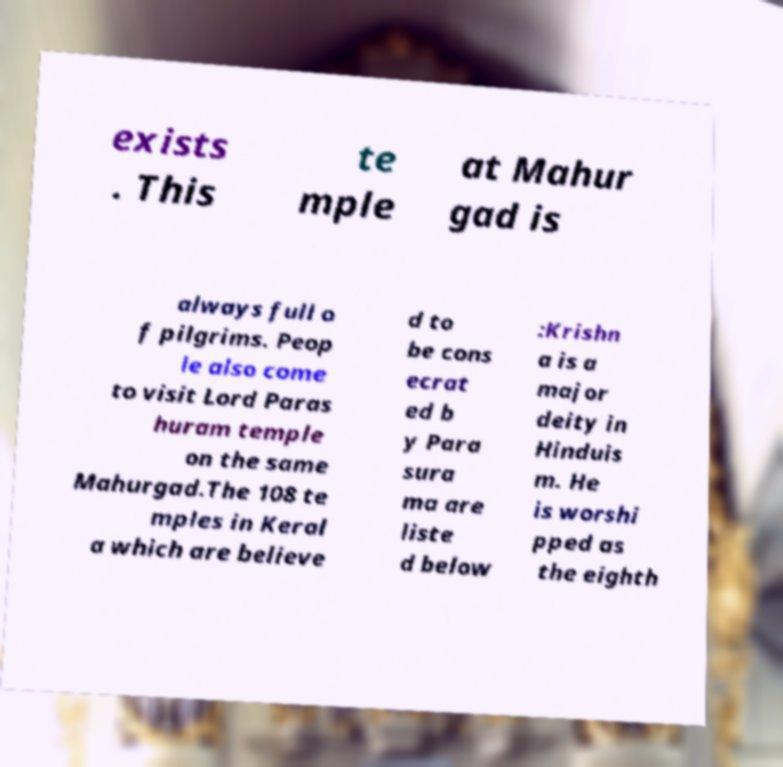Can you read and provide the text displayed in the image?This photo seems to have some interesting text. Can you extract and type it out for me? exists . This te mple at Mahur gad is always full o f pilgrims. Peop le also come to visit Lord Paras huram temple on the same Mahurgad.The 108 te mples in Keral a which are believe d to be cons ecrat ed b y Para sura ma are liste d below :Krishn a is a major deity in Hinduis m. He is worshi pped as the eighth 